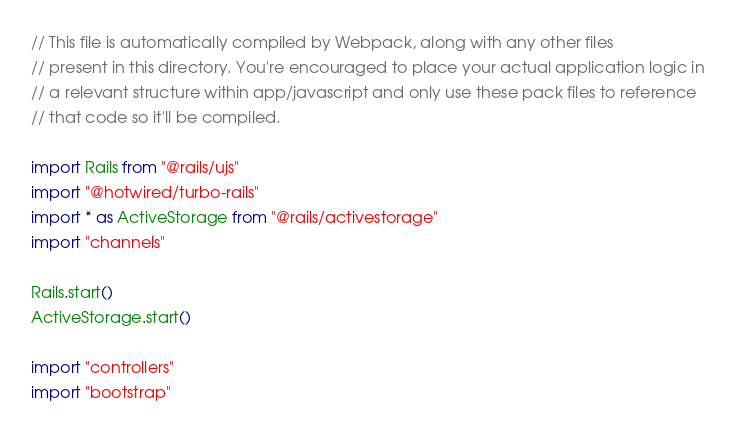<code> <loc_0><loc_0><loc_500><loc_500><_JavaScript_>// This file is automatically compiled by Webpack, along with any other files
// present in this directory. You're encouraged to place your actual application logic in
// a relevant structure within app/javascript and only use these pack files to reference
// that code so it'll be compiled.

import Rails from "@rails/ujs"
import "@hotwired/turbo-rails"
import * as ActiveStorage from "@rails/activestorage"
import "channels"

Rails.start()
ActiveStorage.start()

import "controllers"
import "bootstrap"
</code> 